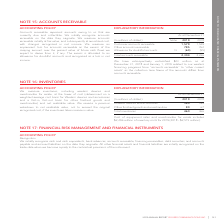According to Rogers Communications's financial document, What does Accounts receivable represent? Accounts receivable represent amounts owing to us that are currently due and collectible. We initially recognize accounts receivable on the date they originate.. The document states: "ACCOUNTING POLICY Accounts receivable represent amounts owing to us that are currently due and collectible. We initially recognize accounts receivable..." Also, How is accounts receivable measured? We measure accounts receivable initially at fair value, and subsequently at amortized cost, with changes recognized in net income.. The document states: "ze accounts receivable on the date they originate. We measure accounts receivable initially at fair value, and subsequently at amortized cost, with ch..." Also, How is impairment loss for accounts receivable measured? We measure an impairment loss for accounts receivable as the excess of the carrying amount over the present value of future cash flows we expect to derive from it, if any.. The document states: "tized cost, with changes recognized in net income. We measure an impairment loss for accounts receivable as the excess of the carrying amount over the..." Also, can you calculate: What is the increase/ (decrease) in Customer accounts receivable from 2018 to 2019? Based on the calculation: 1,579-1,529, the result is 50 (in millions). This is based on the information: "Customer accounts receivable 1,579 1,529 Other accounts receivable 785 762 Allowance for doubtful accounts 15 (60) (55) Customer accounts receivable 1,579 1,529 Other accounts receivable 785 762 Allow..." The key data points involved are: 1,529, 1,579. Also, can you calculate: What is the increase/ (decrease) in Other accounts receivable from 2018 to 2019? Based on the calculation: 785-762, the result is 23 (in millions). This is based on the information: "eivable 1,579 1,529 Other accounts receivable 785 762 Allowance for doubtful accounts 15 (60) (55) receivable 1,579 1,529 Other accounts receivable 785 762 Allowance for doubtful accounts 15 (60) (55)..." The key data points involved are: 762, 785. Also, can you calculate: What is the increase/ (decrease) in Allowance for doubtful accounts from 2018 to 2019? Based on the calculation: 60-55, the result is 5 (in millions). This is based on the information: "vable 785 762 Allowance for doubtful accounts 15 (60) (55) 785 762 Allowance for doubtful accounts 15 (60) (55)..." The key data points involved are: 55, 60. 